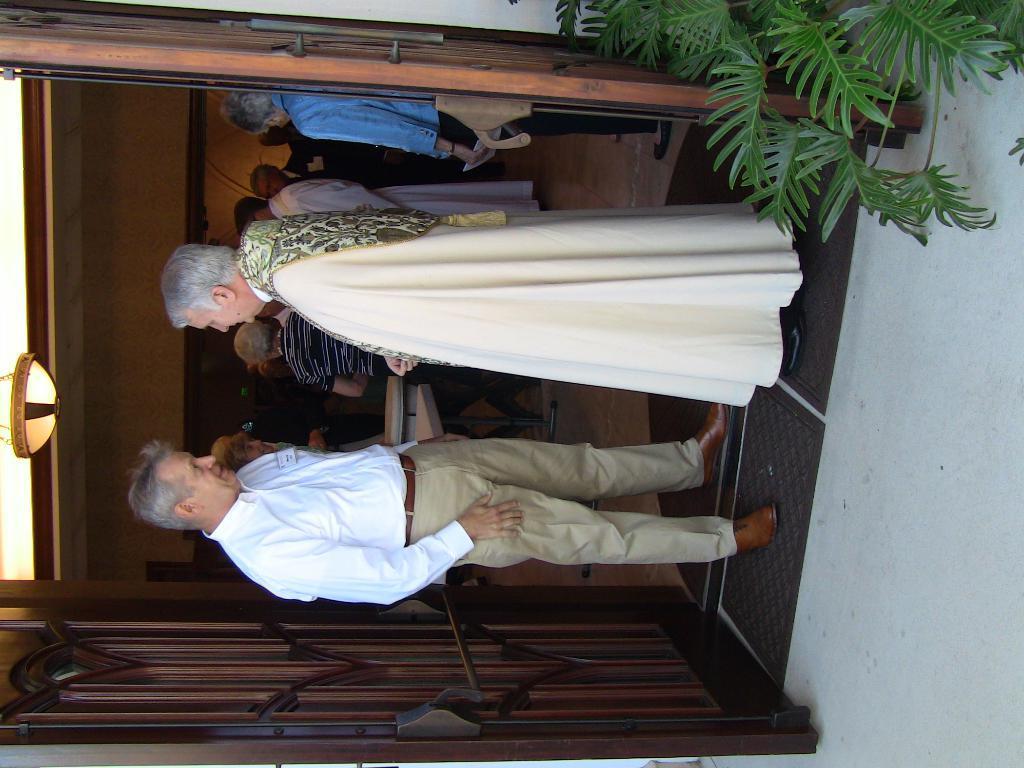Can you describe this image briefly? This picture is in left side direction. In this image there are group of people standing inside the room and there are two people standing at the entrance and there is a door. At the top there is a light. At the bottom there is a floor and there are mars and there is a plant. 